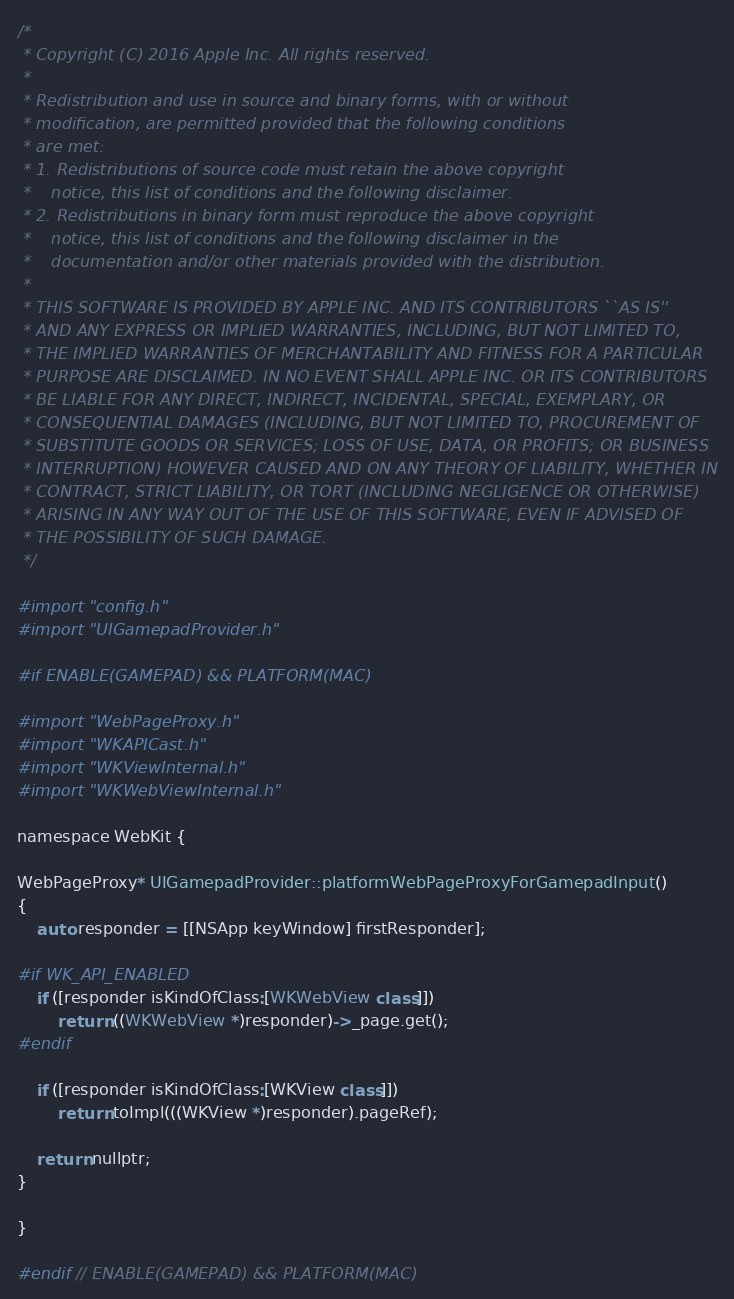<code> <loc_0><loc_0><loc_500><loc_500><_ObjectiveC_>/*
 * Copyright (C) 2016 Apple Inc. All rights reserved.
 *
 * Redistribution and use in source and binary forms, with or without
 * modification, are permitted provided that the following conditions
 * are met:
 * 1. Redistributions of source code must retain the above copyright
 *    notice, this list of conditions and the following disclaimer.
 * 2. Redistributions in binary form must reproduce the above copyright
 *    notice, this list of conditions and the following disclaimer in the
 *    documentation and/or other materials provided with the distribution.
 *
 * THIS SOFTWARE IS PROVIDED BY APPLE INC. AND ITS CONTRIBUTORS ``AS IS''
 * AND ANY EXPRESS OR IMPLIED WARRANTIES, INCLUDING, BUT NOT LIMITED TO,
 * THE IMPLIED WARRANTIES OF MERCHANTABILITY AND FITNESS FOR A PARTICULAR
 * PURPOSE ARE DISCLAIMED. IN NO EVENT SHALL APPLE INC. OR ITS CONTRIBUTORS
 * BE LIABLE FOR ANY DIRECT, INDIRECT, INCIDENTAL, SPECIAL, EXEMPLARY, OR
 * CONSEQUENTIAL DAMAGES (INCLUDING, BUT NOT LIMITED TO, PROCUREMENT OF
 * SUBSTITUTE GOODS OR SERVICES; LOSS OF USE, DATA, OR PROFITS; OR BUSINESS
 * INTERRUPTION) HOWEVER CAUSED AND ON ANY THEORY OF LIABILITY, WHETHER IN
 * CONTRACT, STRICT LIABILITY, OR TORT (INCLUDING NEGLIGENCE OR OTHERWISE)
 * ARISING IN ANY WAY OUT OF THE USE OF THIS SOFTWARE, EVEN IF ADVISED OF
 * THE POSSIBILITY OF SUCH DAMAGE.
 */

#import "config.h"
#import "UIGamepadProvider.h"

#if ENABLE(GAMEPAD) && PLATFORM(MAC)

#import "WebPageProxy.h"
#import "WKAPICast.h"
#import "WKViewInternal.h"
#import "WKWebViewInternal.h"

namespace WebKit {

WebPageProxy* UIGamepadProvider::platformWebPageProxyForGamepadInput()
{
    auto responder = [[NSApp keyWindow] firstResponder];

#if WK_API_ENABLED
    if ([responder isKindOfClass:[WKWebView class]])
        return ((WKWebView *)responder)->_page.get();
#endif

    if ([responder isKindOfClass:[WKView class]])
        return toImpl(((WKView *)responder).pageRef);

    return nullptr;
}

}

#endif // ENABLE(GAMEPAD) && PLATFORM(MAC)
</code> 